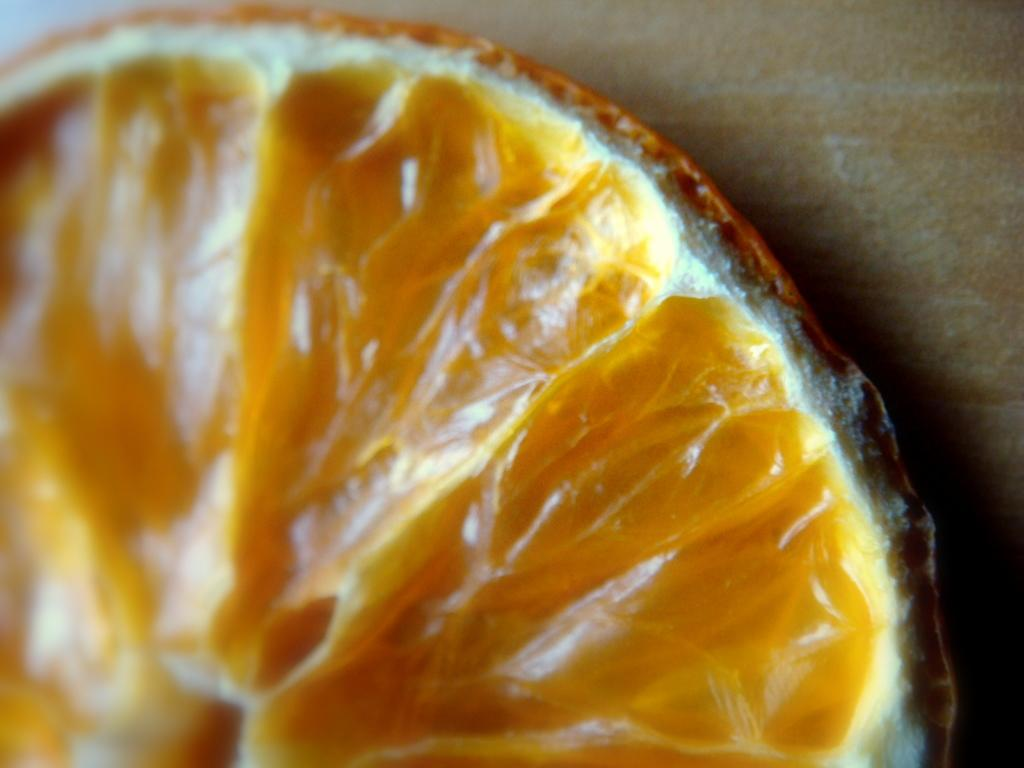What is located on the surface in the foreground of the image? There is an orange slice on the surface in the foreground of the image. What type of medical advice can be heard from the doctor in the image? There is no doctor present in the image, so no medical advice can be heard. 